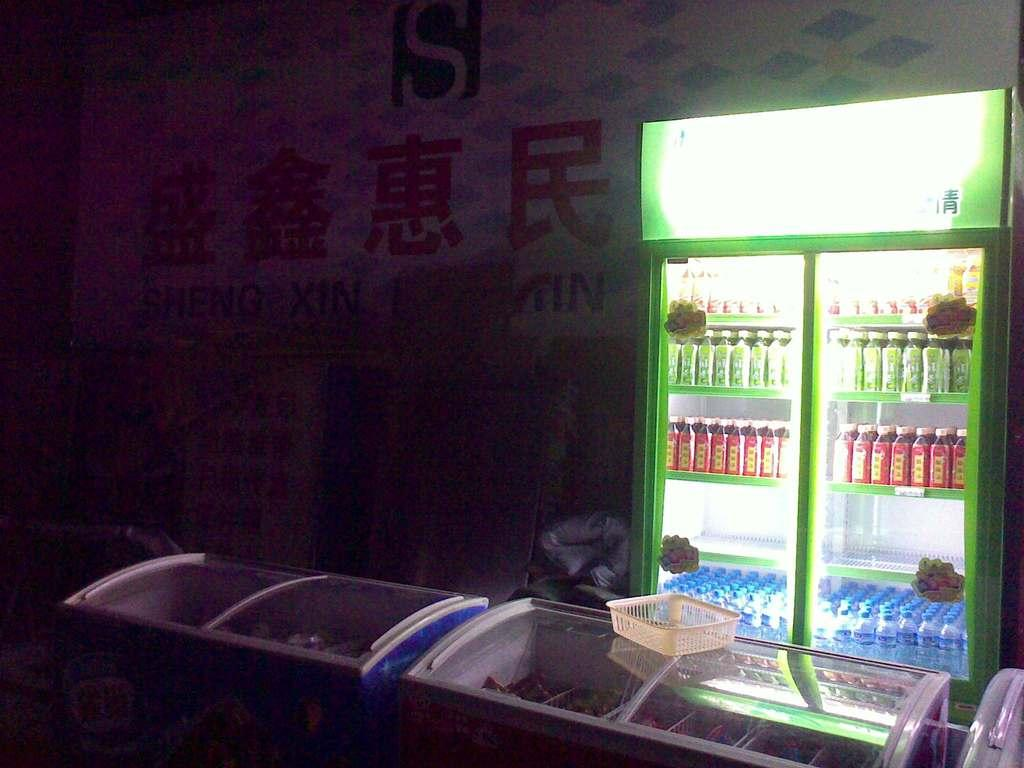<image>
Give a short and clear explanation of the subsequent image. The inside of an Asian store with a large green letter S at the top. 